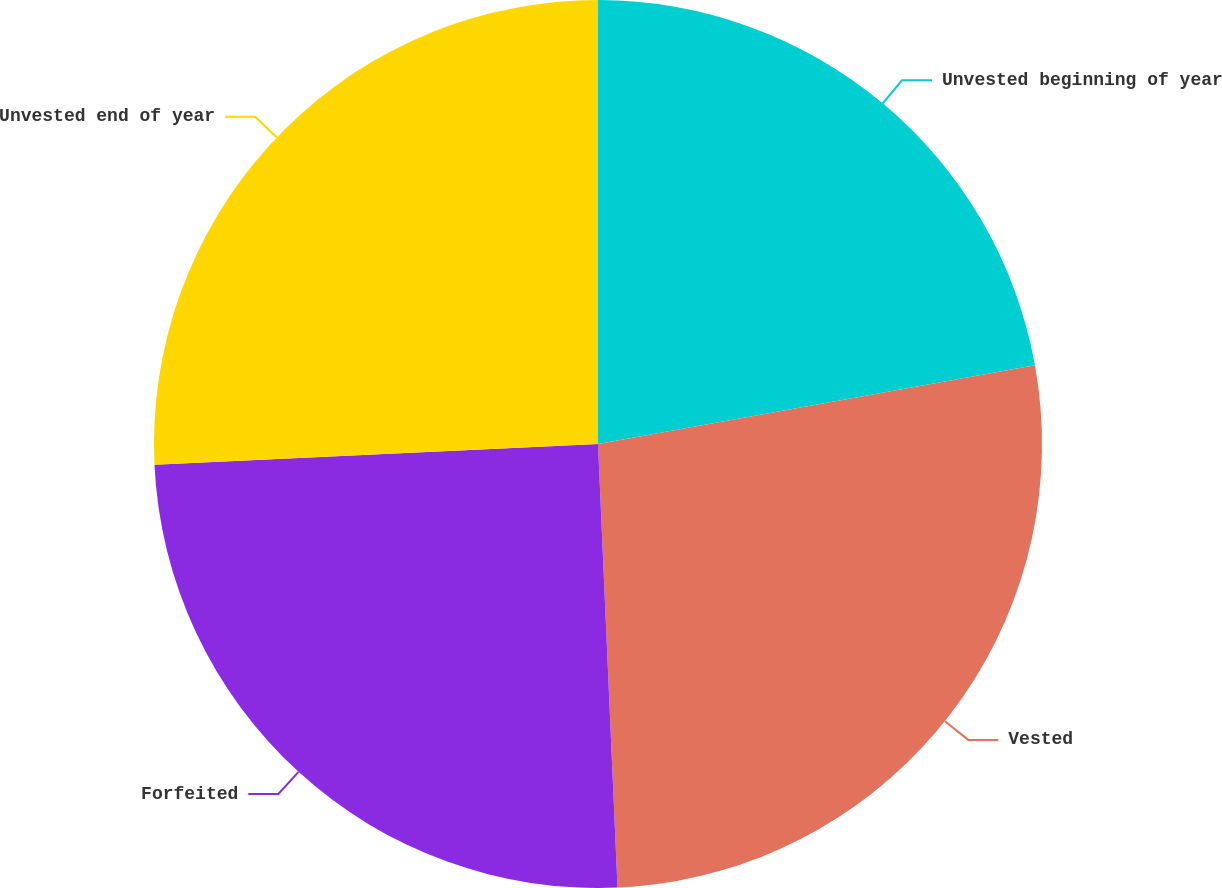Convert chart to OTSL. <chart><loc_0><loc_0><loc_500><loc_500><pie_chart><fcel>Unvested beginning of year<fcel>Vested<fcel>Forfeited<fcel>Unvested end of year<nl><fcel>22.16%<fcel>27.14%<fcel>24.96%<fcel>25.74%<nl></chart> 